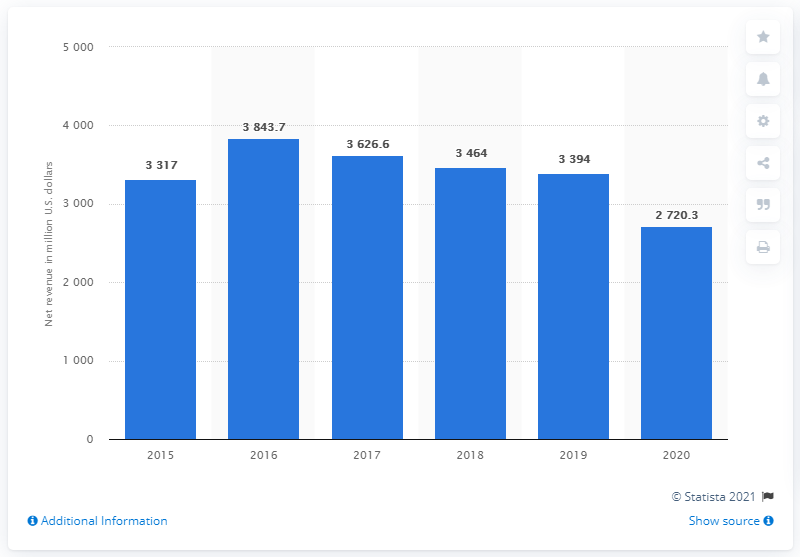Highlight a few significant elements in this photo. In 2020, Under Armour's net revenue in the United States was approximately 2,720.3 million dollars. During the period of 2016 to 2020, Under Armour's net revenue fell by 27.203 million dollars. 